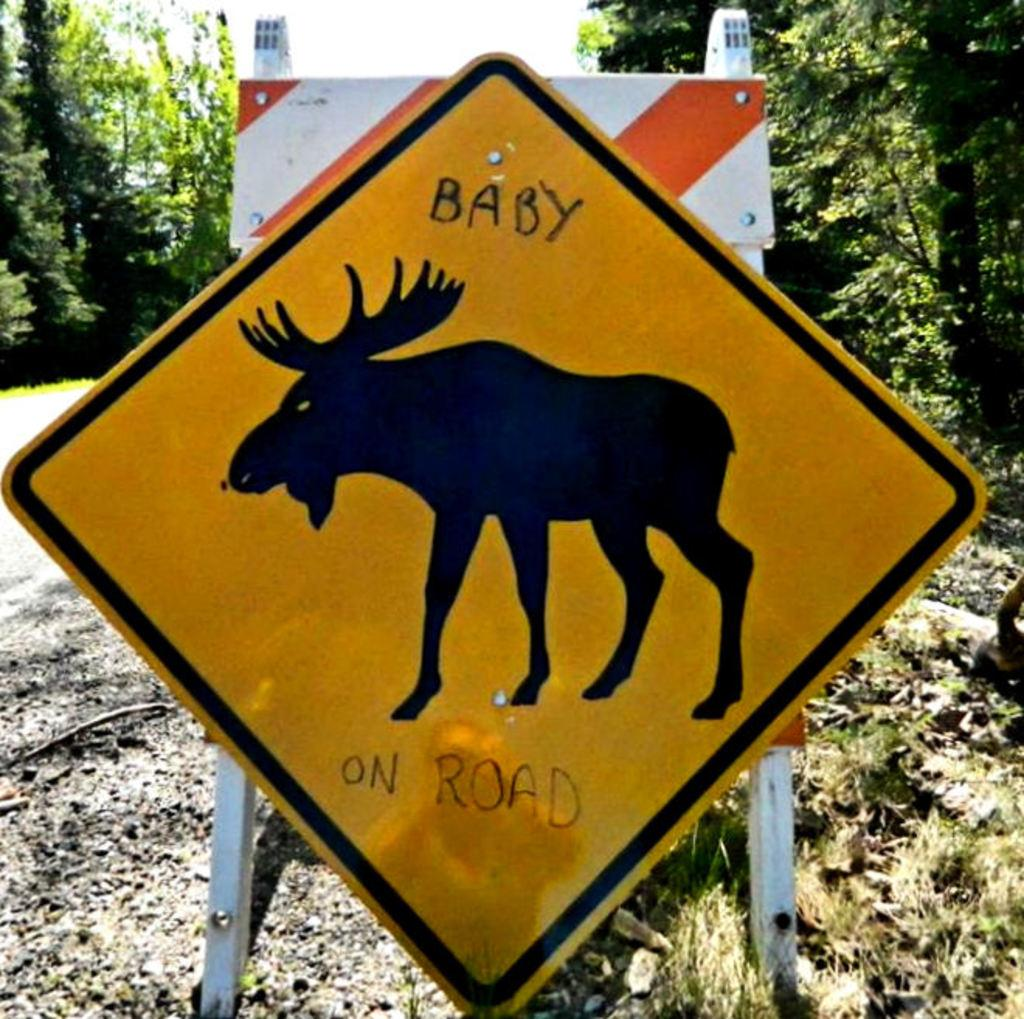What is the main structure in the image? There is a board with poles in the image. What type of terrain is visible in the image? There is grass visible in the image. What type of pathway is present in the image? There is a road in the image. What can be seen in the distance in the image? There are trees and plants in the background of the image. What type of cord is being used to hang the glove in the image? There is no glove or cord present in the image. What is the main character's desire in the image? There is no main character or desire depicted in the image. 